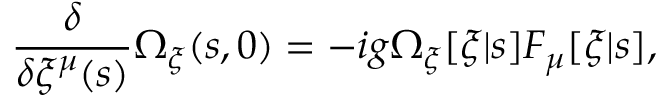<formula> <loc_0><loc_0><loc_500><loc_500>\frac { \delta } { \delta \xi ^ { \mu } ( s ) } \Omega _ { \xi } ( s , 0 ) = - i g \Omega _ { \xi } [ \xi | s ] F _ { \mu } [ \xi | s ] ,</formula> 